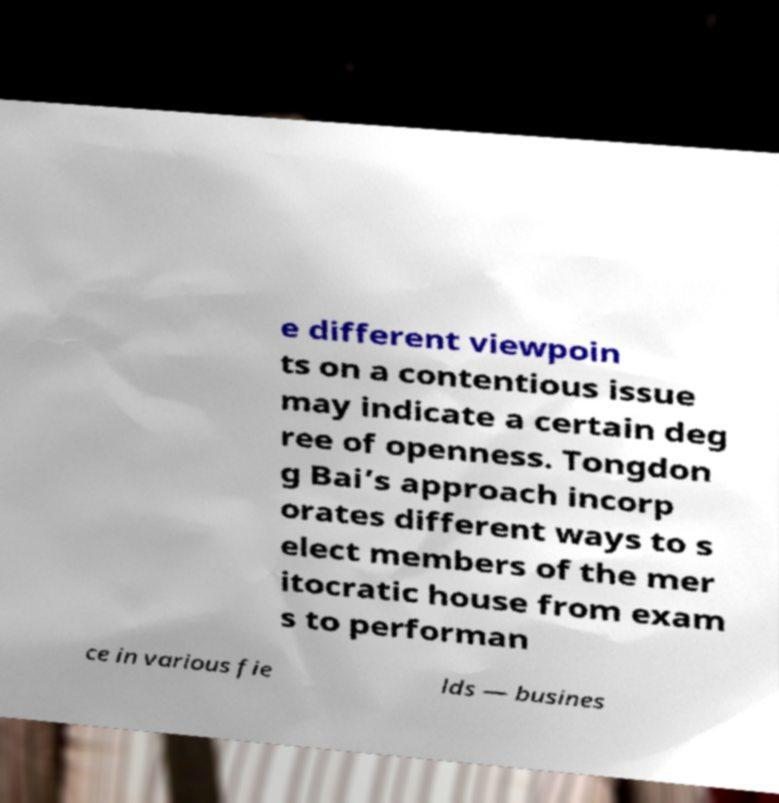Please read and relay the text visible in this image. What does it say? e different viewpoin ts on a contentious issue may indicate a certain deg ree of openness. Tongdon g Bai’s approach incorp orates different ways to s elect members of the mer itocratic house from exam s to performan ce in various fie lds — busines 